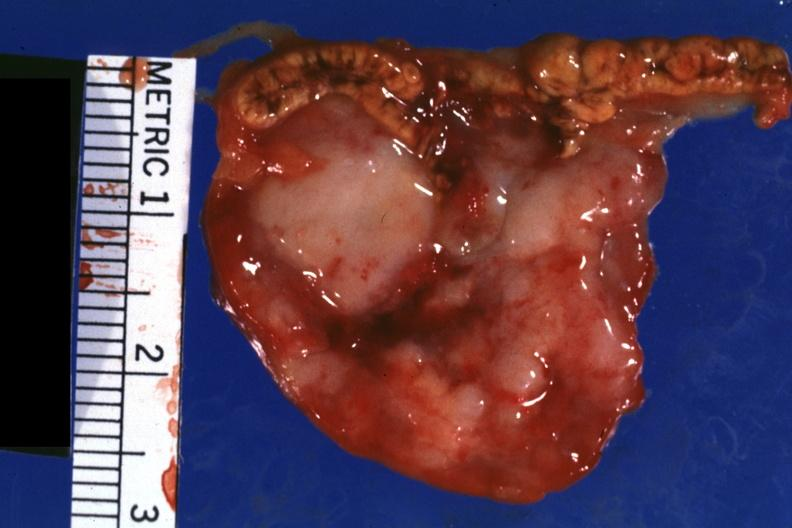s anencephaly present?
Answer the question using a single word or phrase. No 